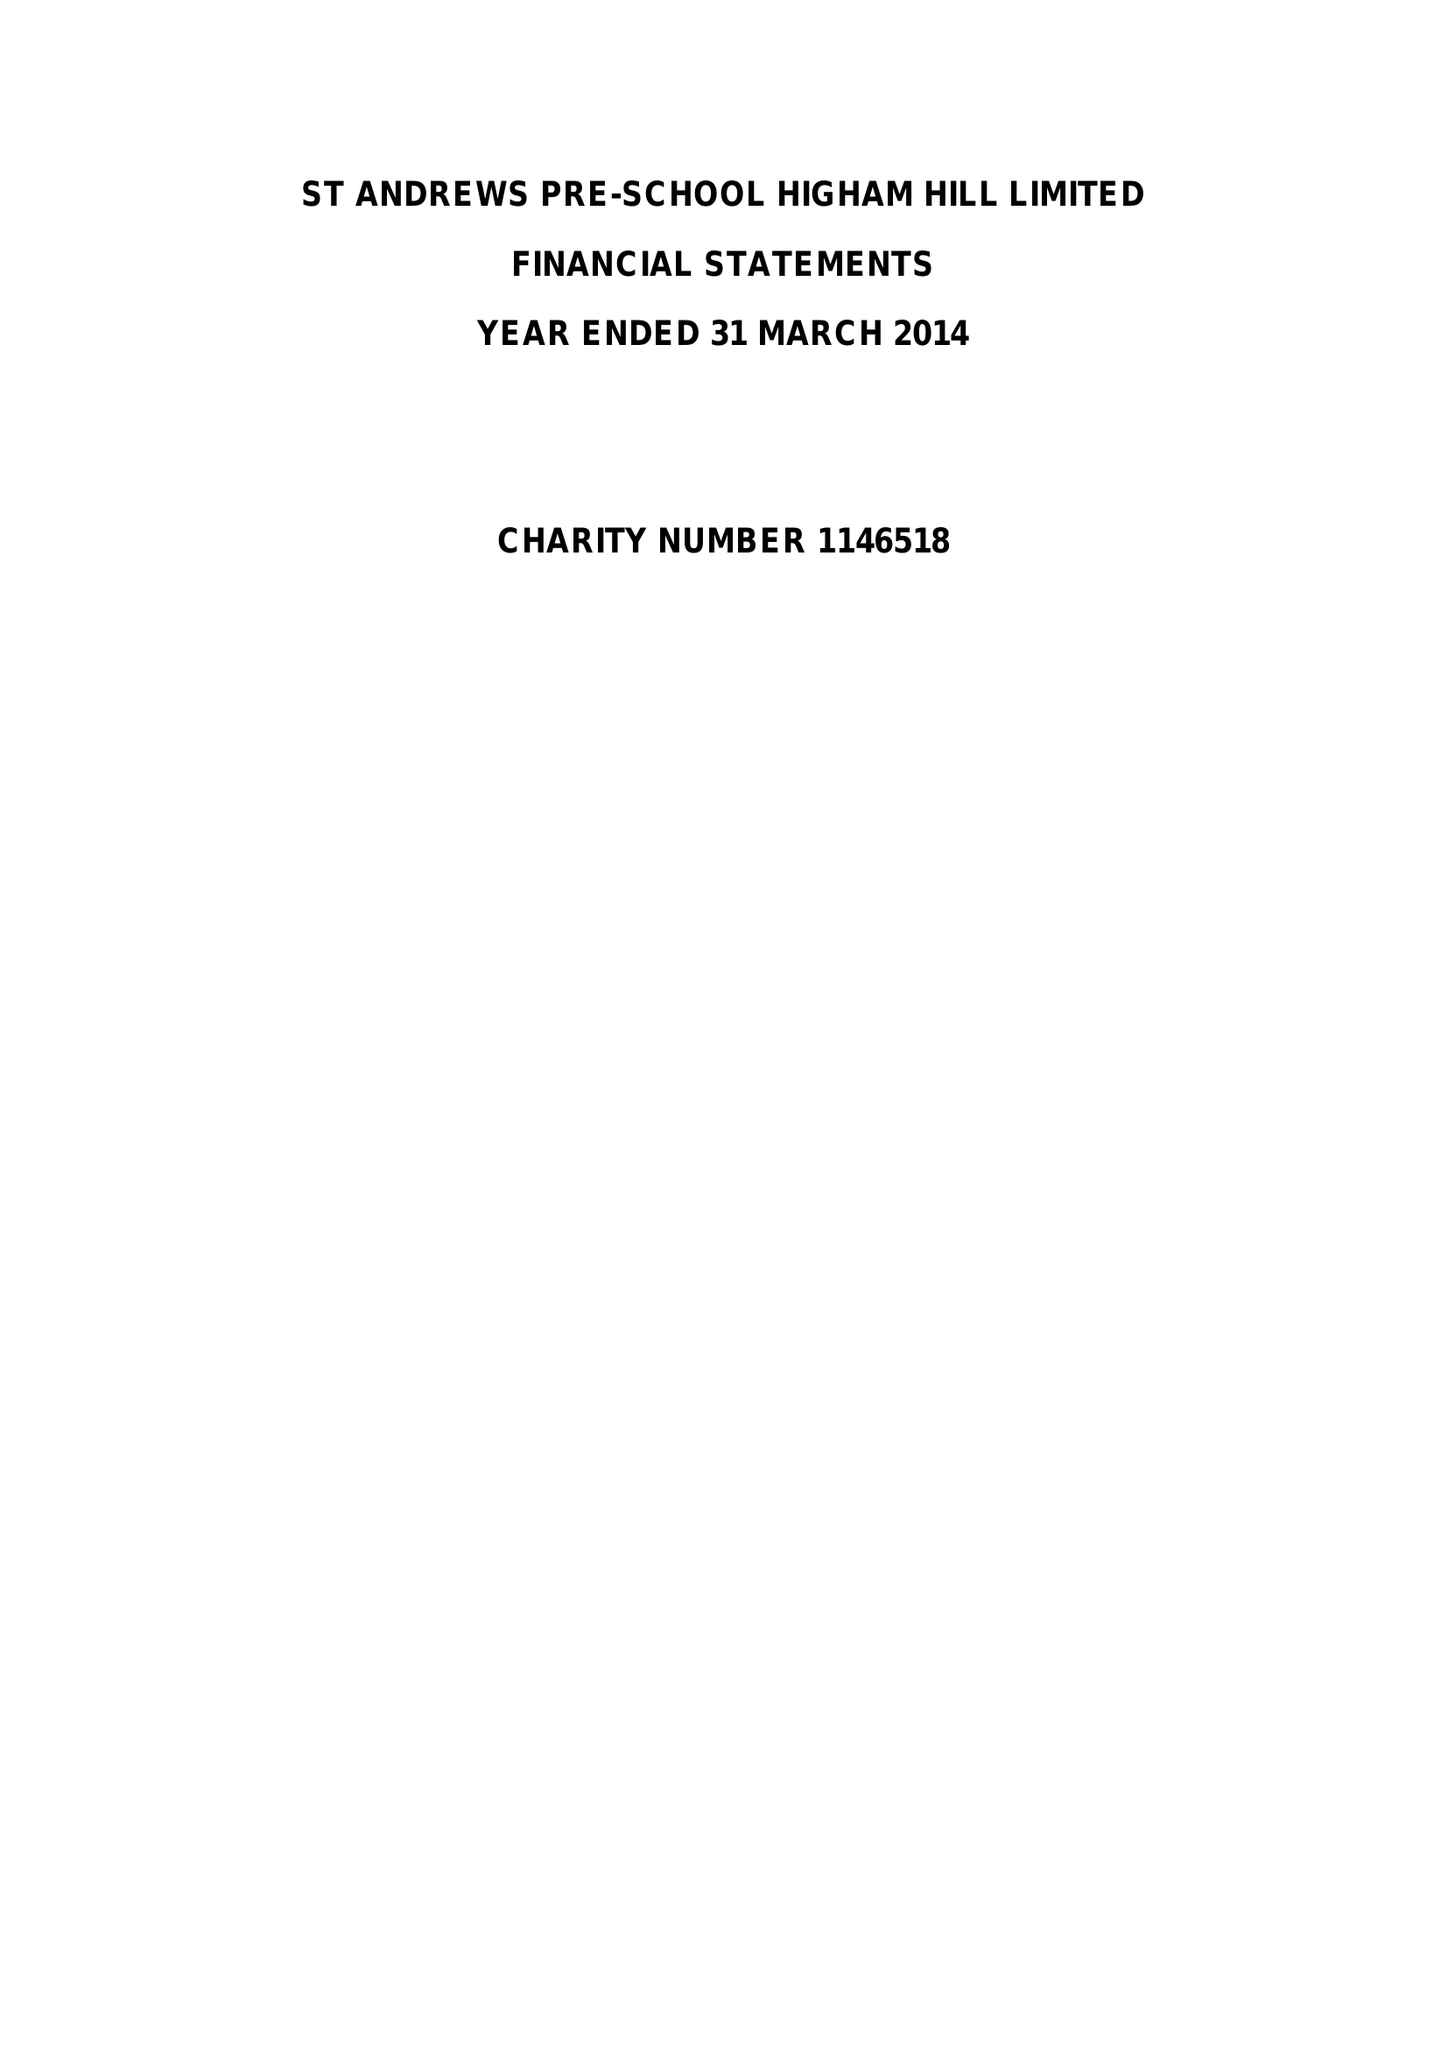What is the value for the address__postcode?
Answer the question using a single word or phrase. E17 6AR 